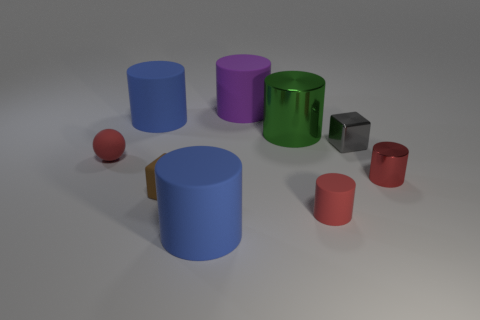Subtract 1 cylinders. How many cylinders are left? 5 Subtract all purple cylinders. How many cylinders are left? 5 Subtract all large purple cylinders. How many cylinders are left? 5 Subtract all cyan cylinders. Subtract all green blocks. How many cylinders are left? 6 Add 1 purple things. How many objects exist? 10 Subtract all cylinders. How many objects are left? 3 Add 5 small red rubber cylinders. How many small red rubber cylinders exist? 6 Subtract 0 blue cubes. How many objects are left? 9 Subtract all small cyan shiny balls. Subtract all large green metal objects. How many objects are left? 8 Add 5 green objects. How many green objects are left? 6 